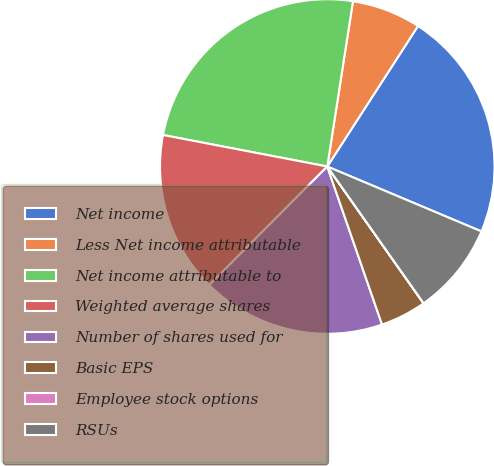Convert chart. <chart><loc_0><loc_0><loc_500><loc_500><pie_chart><fcel>Net income<fcel>Less Net income attributable<fcel>Net income attributable to<fcel>Weighted average shares<fcel>Number of shares used for<fcel>Basic EPS<fcel>Employee stock options<fcel>RSUs<nl><fcel>22.22%<fcel>6.67%<fcel>24.44%<fcel>15.55%<fcel>17.78%<fcel>4.45%<fcel>0.01%<fcel>8.89%<nl></chart> 